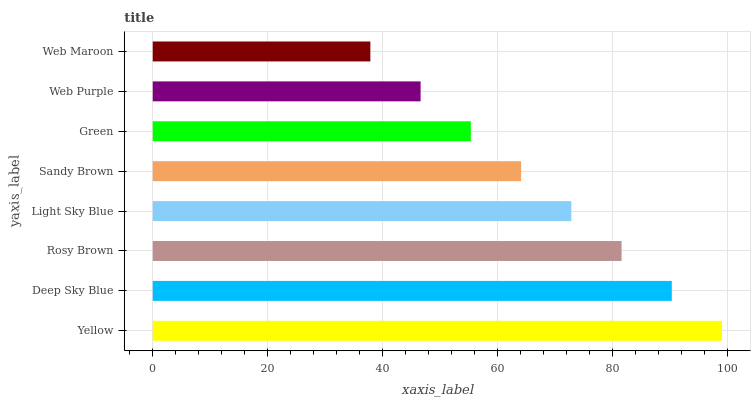Is Web Maroon the minimum?
Answer yes or no. Yes. Is Yellow the maximum?
Answer yes or no. Yes. Is Deep Sky Blue the minimum?
Answer yes or no. No. Is Deep Sky Blue the maximum?
Answer yes or no. No. Is Yellow greater than Deep Sky Blue?
Answer yes or no. Yes. Is Deep Sky Blue less than Yellow?
Answer yes or no. Yes. Is Deep Sky Blue greater than Yellow?
Answer yes or no. No. Is Yellow less than Deep Sky Blue?
Answer yes or no. No. Is Light Sky Blue the high median?
Answer yes or no. Yes. Is Sandy Brown the low median?
Answer yes or no. Yes. Is Sandy Brown the high median?
Answer yes or no. No. Is Light Sky Blue the low median?
Answer yes or no. No. 